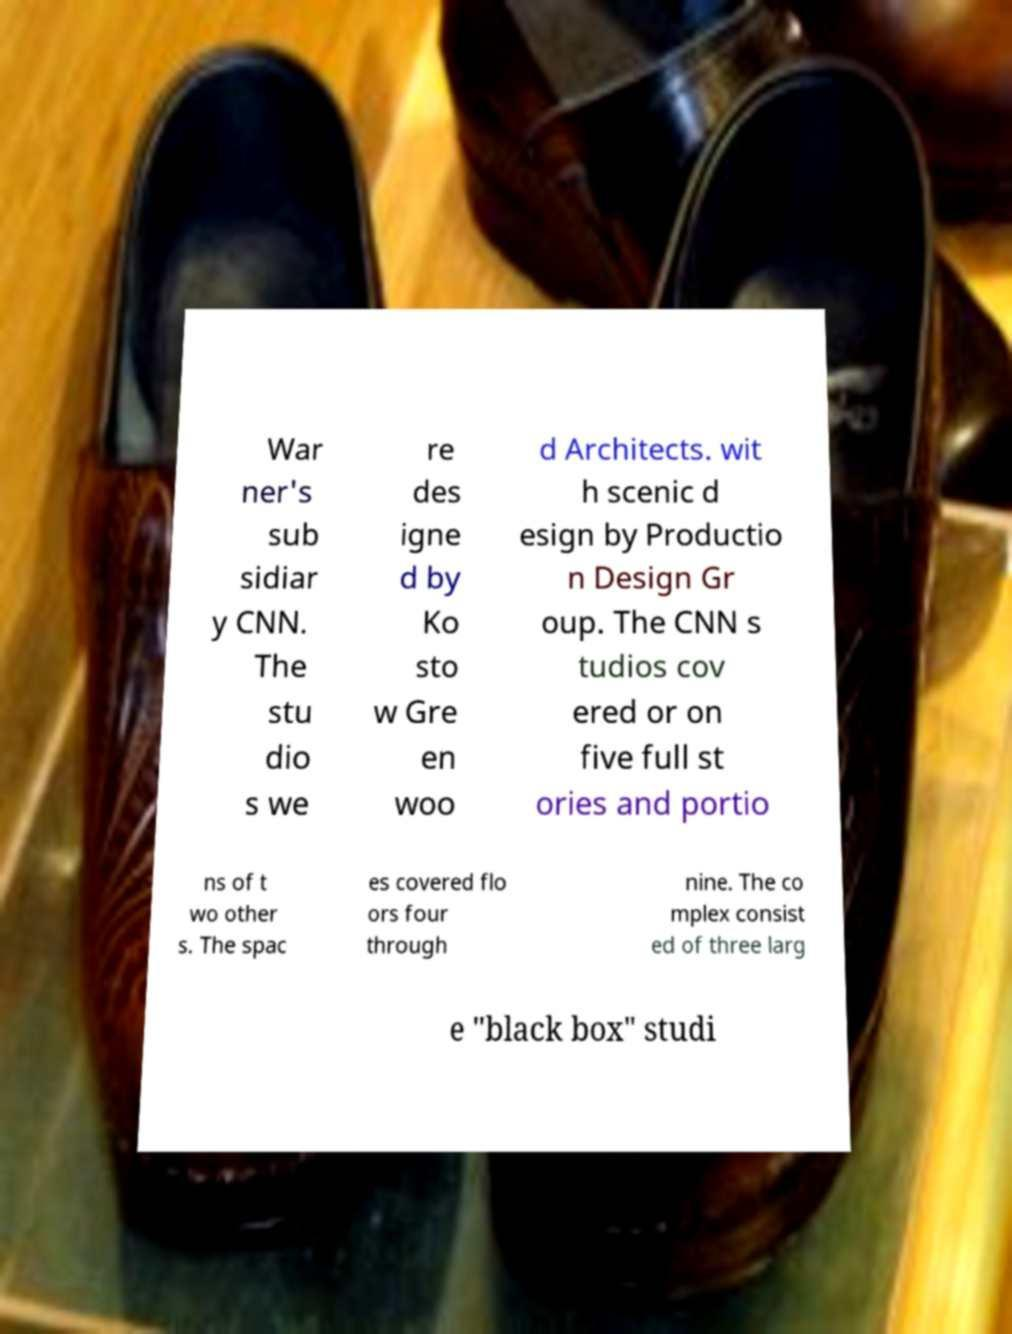Please read and relay the text visible in this image. What does it say? War ner's sub sidiar y CNN. The stu dio s we re des igne d by Ko sto w Gre en woo d Architects. wit h scenic d esign by Productio n Design Gr oup. The CNN s tudios cov ered or on five full st ories and portio ns of t wo other s. The spac es covered flo ors four through nine. The co mplex consist ed of three larg e "black box" studi 